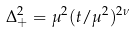Convert formula to latex. <formula><loc_0><loc_0><loc_500><loc_500>\Delta _ { + } ^ { 2 } = \mu ^ { 2 } ( t / \mu ^ { 2 } ) ^ { 2 \nu }</formula> 